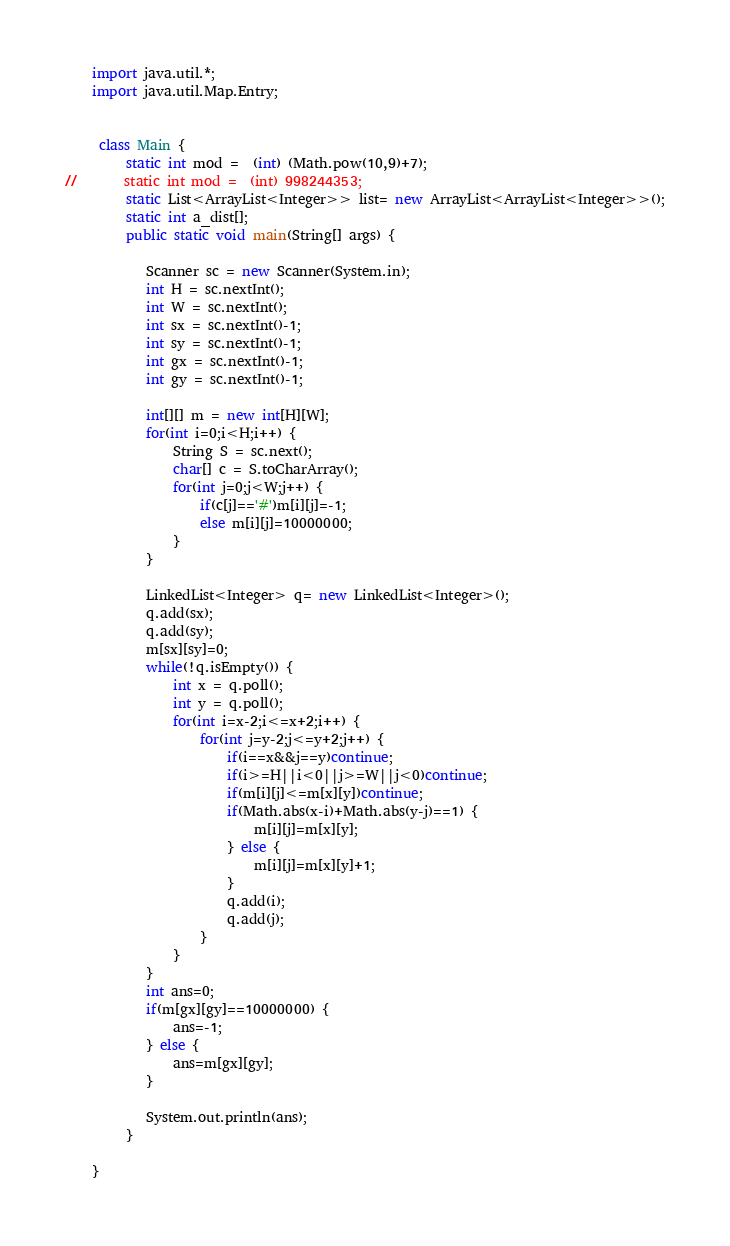<code> <loc_0><loc_0><loc_500><loc_500><_Java_>	import java.util.*;
	import java.util.Map.Entry;
	 
	 
	 class Main {
		 static int mod =  (int) (Math.pow(10,9)+7);
//		 static int mod =  (int) 998244353;
		 static List<ArrayList<Integer>> list= new ArrayList<ArrayList<Integer>>();
		 static int a_dist[];
		 public static void main(String[] args) {
	    	
	        Scanner sc = new Scanner(System.in);
	        int H = sc.nextInt();
	        int W = sc.nextInt();
	        int sx = sc.nextInt()-1;
	        int sy = sc.nextInt()-1;
	        int gx = sc.nextInt()-1;
	        int gy = sc.nextInt()-1;
	        
	        int[][] m = new int[H][W];
	        for(int i=0;i<H;i++) {
		        String S = sc.next();
		        char[] c = S.toCharArray();
		        for(int j=0;j<W;j++) {
		        	if(c[j]=='#')m[i][j]=-1;
		        	else m[i][j]=10000000;
		        }
	        }
	        
			LinkedList<Integer> q= new LinkedList<Integer>();
			q.add(sx);
			q.add(sy);
			m[sx][sy]=0;
	        while(!q.isEmpty()) {
	        	int x = q.poll();
	        	int y = q.poll();
	        	for(int i=x-2;i<=x+2;i++) {
	        		for(int j=y-2;j<=y+2;j++) {
	        			if(i==x&&j==y)continue;
	        			if(i>=H||i<0||j>=W||j<0)continue;
	        			if(m[i][j]<=m[x][y])continue;
	        			if(Math.abs(x-i)+Math.abs(y-j)==1) {
	        				m[i][j]=m[x][y];
	        			} else {
	        				m[i][j]=m[x][y]+1;	        				
	        			}
        				q.add(i);
        				q.add(j);
	        		}
	        	}
	        }
        	int ans=0;
        	if(m[gx][gy]==10000000) {
        		ans=-1;
        	} else {
        		ans=m[gx][gy];
        	}
	        
	        System.out.println(ans);
		 }
		 
	}</code> 